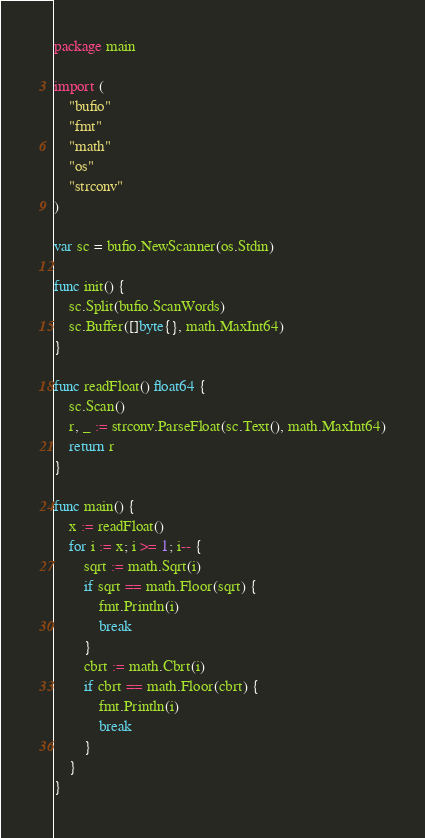Convert code to text. <code><loc_0><loc_0><loc_500><loc_500><_Go_>package main

import (
	"bufio"
	"fmt"
	"math"
	"os"
	"strconv"
)

var sc = bufio.NewScanner(os.Stdin)

func init() {
	sc.Split(bufio.ScanWords)
	sc.Buffer([]byte{}, math.MaxInt64)
}

func readFloat() float64 {
	sc.Scan()
	r, _ := strconv.ParseFloat(sc.Text(), math.MaxInt64)
	return r
}

func main() {
	x := readFloat()
	for i := x; i >= 1; i-- {
		sqrt := math.Sqrt(i)
		if sqrt == math.Floor(sqrt) {
			fmt.Println(i)
			break
		}
		cbrt := math.Cbrt(i)
		if cbrt == math.Floor(cbrt) {
			fmt.Println(i)
			break
		}
	}
}
</code> 